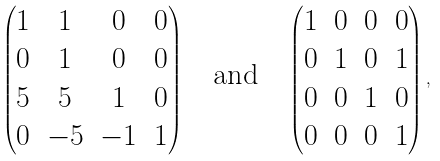<formula> <loc_0><loc_0><loc_500><loc_500>\begin{pmatrix} 1 & 1 & 0 & 0 \\ 0 & 1 & 0 & 0 \\ 5 & 5 & 1 & 0 \\ 0 & - 5 & - 1 & 1 \end{pmatrix} \quad \text {and} \quad \begin{pmatrix} 1 & 0 & 0 & 0 \\ 0 & 1 & 0 & 1 \\ 0 & 0 & 1 & 0 \\ 0 & 0 & 0 & 1 \end{pmatrix} ,</formula> 